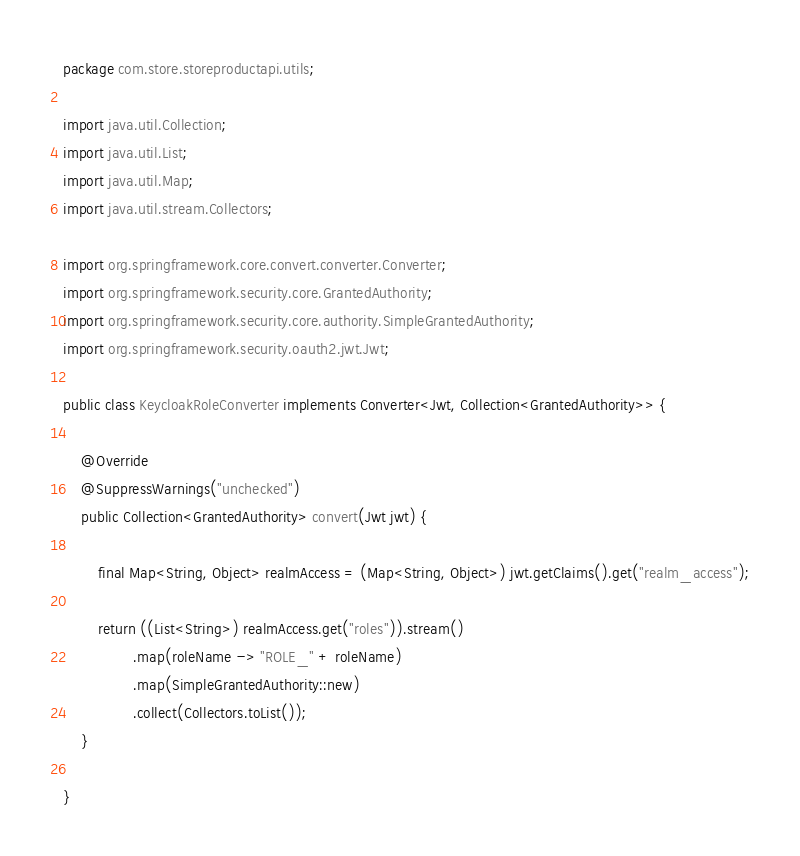<code> <loc_0><loc_0><loc_500><loc_500><_Java_>package com.store.storeproductapi.utils;

import java.util.Collection;
import java.util.List;
import java.util.Map;
import java.util.stream.Collectors;

import org.springframework.core.convert.converter.Converter;
import org.springframework.security.core.GrantedAuthority;
import org.springframework.security.core.authority.SimpleGrantedAuthority;
import org.springframework.security.oauth2.jwt.Jwt;

public class KeycloakRoleConverter implements Converter<Jwt, Collection<GrantedAuthority>> {

    @Override
    @SuppressWarnings("unchecked")
    public Collection<GrantedAuthority> convert(Jwt jwt) {

        final Map<String, Object> realmAccess = (Map<String, Object>) jwt.getClaims().get("realm_access");

        return ((List<String>) realmAccess.get("roles")).stream()
                .map(roleName -> "ROLE_" + roleName)
                .map(SimpleGrantedAuthority::new)
                .collect(Collectors.toList());
    }
    
}
</code> 